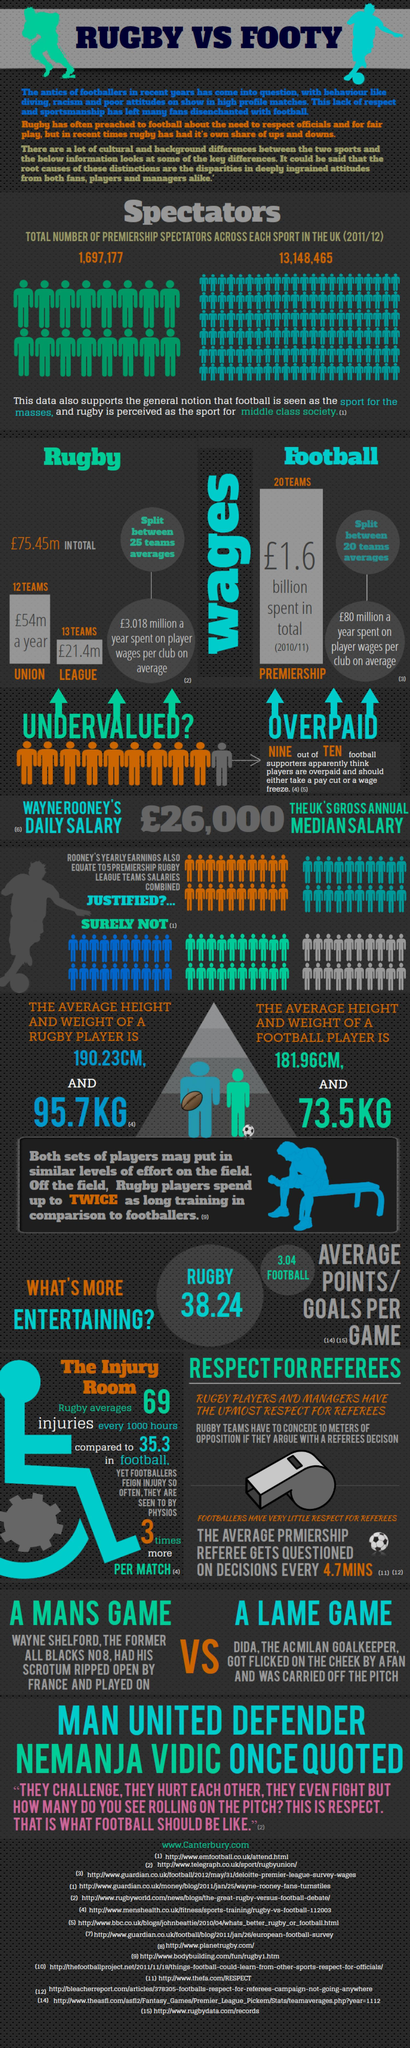Identify some key points in this picture. The sport that had the most number of spectators in 2011-12 in the United Kingdom was football. The average weight of a rugby player is 95.7 kg. 